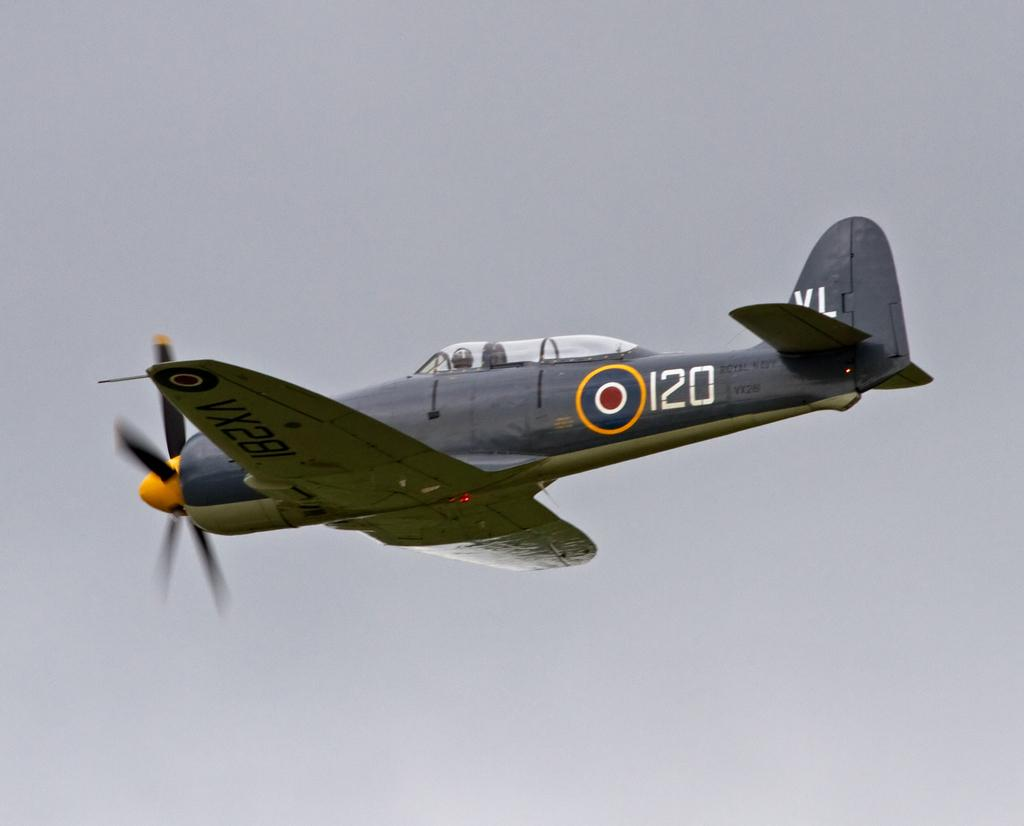Provide a one-sentence caption for the provided image. An old plane with 120 on the side flies in the sky. 